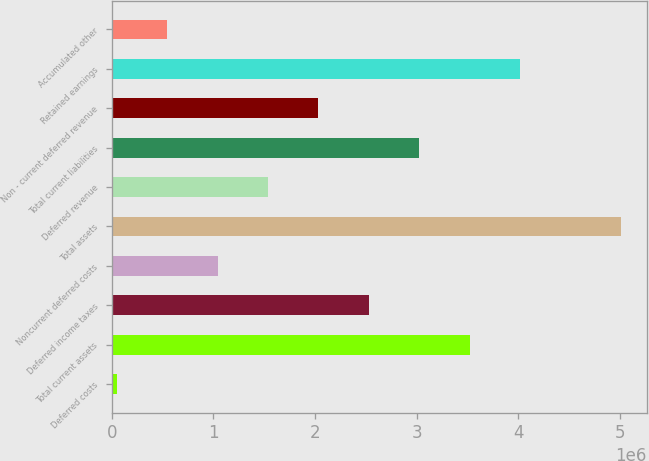<chart> <loc_0><loc_0><loc_500><loc_500><bar_chart><fcel>Deferred costs<fcel>Total current assets<fcel>Deferred income taxes<fcel>Noncurrent deferred costs<fcel>Total assets<fcel>Deferred revenue<fcel>Total current liabilities<fcel>Non - current deferred revenue<fcel>Retained earnings<fcel>Accumulated other<nl><fcel>48312<fcel>3.52168e+06<fcel>2.52929e+06<fcel>1.0407e+06<fcel>5.01026e+06<fcel>1.5369e+06<fcel>3.02548e+06<fcel>2.03309e+06<fcel>4.01787e+06<fcel>544507<nl></chart> 